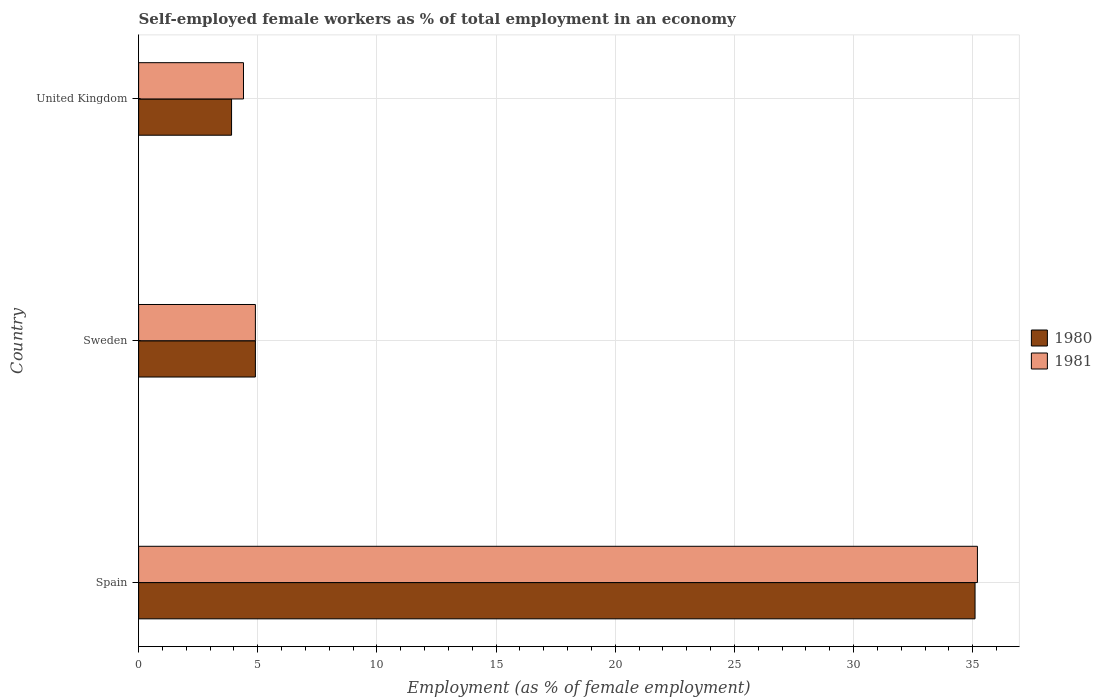How many different coloured bars are there?
Give a very brief answer. 2. How many groups of bars are there?
Your response must be concise. 3. How many bars are there on the 1st tick from the top?
Provide a succinct answer. 2. What is the label of the 2nd group of bars from the top?
Your response must be concise. Sweden. What is the percentage of self-employed female workers in 1981 in United Kingdom?
Offer a terse response. 4.4. Across all countries, what is the maximum percentage of self-employed female workers in 1980?
Your answer should be compact. 35.1. Across all countries, what is the minimum percentage of self-employed female workers in 1980?
Your answer should be compact. 3.9. In which country was the percentage of self-employed female workers in 1980 maximum?
Your answer should be compact. Spain. What is the total percentage of self-employed female workers in 1980 in the graph?
Your answer should be very brief. 43.9. What is the difference between the percentage of self-employed female workers in 1981 in United Kingdom and the percentage of self-employed female workers in 1980 in Sweden?
Keep it short and to the point. -0.5. What is the average percentage of self-employed female workers in 1980 per country?
Make the answer very short. 14.63. What is the ratio of the percentage of self-employed female workers in 1981 in Spain to that in United Kingdom?
Ensure brevity in your answer.  8. Is the percentage of self-employed female workers in 1980 in Spain less than that in United Kingdom?
Keep it short and to the point. No. Is the difference between the percentage of self-employed female workers in 1980 in Spain and Sweden greater than the difference between the percentage of self-employed female workers in 1981 in Spain and Sweden?
Provide a succinct answer. No. What is the difference between the highest and the second highest percentage of self-employed female workers in 1981?
Provide a succinct answer. 30.3. What is the difference between the highest and the lowest percentage of self-employed female workers in 1980?
Provide a short and direct response. 31.2. In how many countries, is the percentage of self-employed female workers in 1980 greater than the average percentage of self-employed female workers in 1980 taken over all countries?
Provide a succinct answer. 1. What does the 2nd bar from the top in Spain represents?
Offer a terse response. 1980. Are all the bars in the graph horizontal?
Give a very brief answer. Yes. How many legend labels are there?
Provide a succinct answer. 2. What is the title of the graph?
Give a very brief answer. Self-employed female workers as % of total employment in an economy. Does "1999" appear as one of the legend labels in the graph?
Offer a terse response. No. What is the label or title of the X-axis?
Provide a short and direct response. Employment (as % of female employment). What is the Employment (as % of female employment) of 1980 in Spain?
Provide a succinct answer. 35.1. What is the Employment (as % of female employment) in 1981 in Spain?
Your answer should be compact. 35.2. What is the Employment (as % of female employment) in 1980 in Sweden?
Give a very brief answer. 4.9. What is the Employment (as % of female employment) in 1981 in Sweden?
Provide a succinct answer. 4.9. What is the Employment (as % of female employment) of 1980 in United Kingdom?
Ensure brevity in your answer.  3.9. What is the Employment (as % of female employment) of 1981 in United Kingdom?
Offer a terse response. 4.4. Across all countries, what is the maximum Employment (as % of female employment) in 1980?
Make the answer very short. 35.1. Across all countries, what is the maximum Employment (as % of female employment) in 1981?
Make the answer very short. 35.2. Across all countries, what is the minimum Employment (as % of female employment) in 1980?
Your response must be concise. 3.9. Across all countries, what is the minimum Employment (as % of female employment) of 1981?
Make the answer very short. 4.4. What is the total Employment (as % of female employment) in 1980 in the graph?
Your response must be concise. 43.9. What is the total Employment (as % of female employment) in 1981 in the graph?
Your response must be concise. 44.5. What is the difference between the Employment (as % of female employment) of 1980 in Spain and that in Sweden?
Provide a succinct answer. 30.2. What is the difference between the Employment (as % of female employment) of 1981 in Spain and that in Sweden?
Your answer should be very brief. 30.3. What is the difference between the Employment (as % of female employment) of 1980 in Spain and that in United Kingdom?
Make the answer very short. 31.2. What is the difference between the Employment (as % of female employment) of 1981 in Spain and that in United Kingdom?
Ensure brevity in your answer.  30.8. What is the difference between the Employment (as % of female employment) in 1981 in Sweden and that in United Kingdom?
Your answer should be very brief. 0.5. What is the difference between the Employment (as % of female employment) of 1980 in Spain and the Employment (as % of female employment) of 1981 in Sweden?
Provide a short and direct response. 30.2. What is the difference between the Employment (as % of female employment) of 1980 in Spain and the Employment (as % of female employment) of 1981 in United Kingdom?
Provide a succinct answer. 30.7. What is the average Employment (as % of female employment) of 1980 per country?
Give a very brief answer. 14.63. What is the average Employment (as % of female employment) in 1981 per country?
Provide a succinct answer. 14.83. What is the difference between the Employment (as % of female employment) of 1980 and Employment (as % of female employment) of 1981 in Sweden?
Your answer should be very brief. 0. What is the ratio of the Employment (as % of female employment) in 1980 in Spain to that in Sweden?
Make the answer very short. 7.16. What is the ratio of the Employment (as % of female employment) in 1981 in Spain to that in Sweden?
Offer a very short reply. 7.18. What is the ratio of the Employment (as % of female employment) of 1980 in Spain to that in United Kingdom?
Make the answer very short. 9. What is the ratio of the Employment (as % of female employment) in 1981 in Spain to that in United Kingdom?
Your response must be concise. 8. What is the ratio of the Employment (as % of female employment) of 1980 in Sweden to that in United Kingdom?
Your answer should be compact. 1.26. What is the ratio of the Employment (as % of female employment) of 1981 in Sweden to that in United Kingdom?
Make the answer very short. 1.11. What is the difference between the highest and the second highest Employment (as % of female employment) in 1980?
Make the answer very short. 30.2. What is the difference between the highest and the second highest Employment (as % of female employment) in 1981?
Ensure brevity in your answer.  30.3. What is the difference between the highest and the lowest Employment (as % of female employment) in 1980?
Your answer should be very brief. 31.2. What is the difference between the highest and the lowest Employment (as % of female employment) of 1981?
Offer a very short reply. 30.8. 